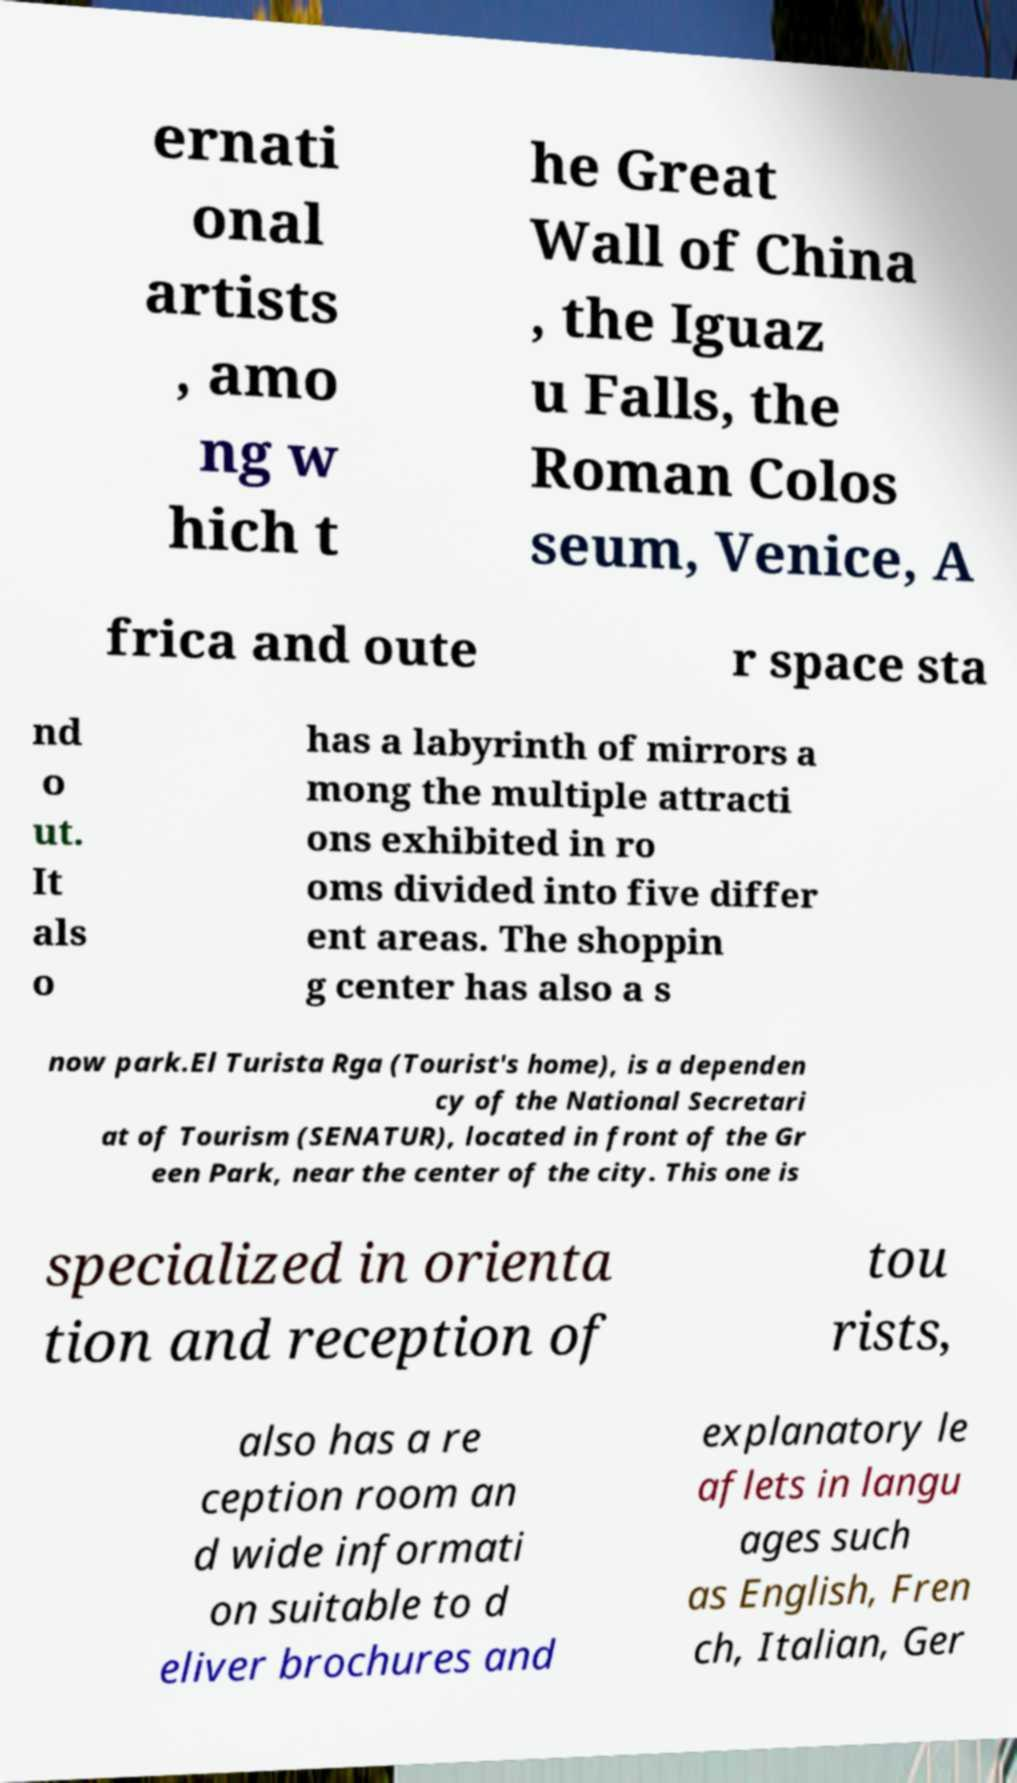Could you assist in decoding the text presented in this image and type it out clearly? ernati onal artists , amo ng w hich t he Great Wall of China , the Iguaz u Falls, the Roman Colos seum, Venice, A frica and oute r space sta nd o ut. It als o has a labyrinth of mirrors a mong the multiple attracti ons exhibited in ro oms divided into five differ ent areas. The shoppin g center has also a s now park.El Turista Rga (Tourist's home), is a dependen cy of the National Secretari at of Tourism (SENATUR), located in front of the Gr een Park, near the center of the city. This one is specialized in orienta tion and reception of tou rists, also has a re ception room an d wide informati on suitable to d eliver brochures and explanatory le aflets in langu ages such as English, Fren ch, Italian, Ger 